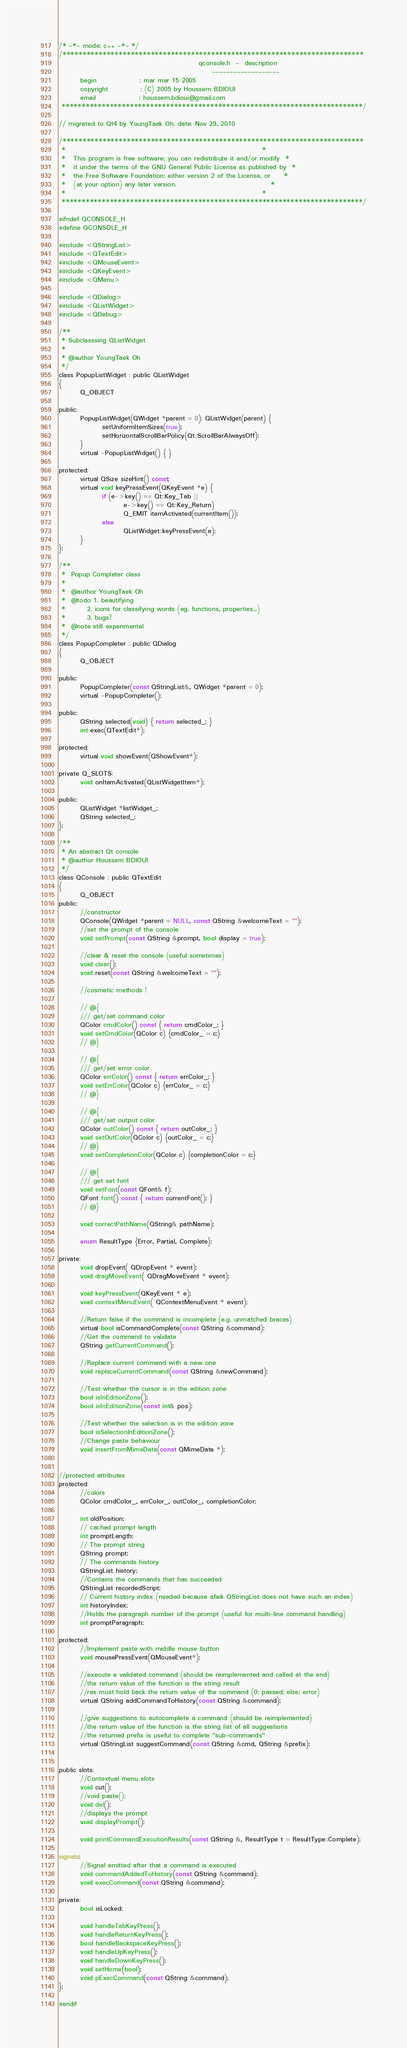Convert code to text. <code><loc_0><loc_0><loc_500><loc_500><_C_>/* -*- mode: c++ -*- */
/***************************************************************************
                                                    qconsole.h  -  description
                                                         -------------------
        begin                : mar mar 15 2005
        copyright            : (C) 2005 by Houssem BDIOUI
        email                : houssem.bdioui@gmail.com
 ***************************************************************************/

// migrated to Qt4 by YoungTaek Oh. date: Nov 29, 2010

/***************************************************************************
 *                                                                         *
 *   This program is free software; you can redistribute it and/or modify  *
 *   it under the terms of the GNU General Public License as published by  *
 *   the Free Software Foundation; either version 2 of the License, or     *
 *   (at your option) any later version.                                   *
 *                                                                         *
 ***************************************************************************/

#ifndef QCONSOLE_H
#define QCONSOLE_H

#include <QStringList>
#include <QTextEdit>
#include <QMouseEvent>
#include <QKeyEvent>
#include <QMenu>

#include <QDialog>
#include <QListWidget>
#include <QDebug>

/**
 * Subclasssing QListWidget
 *
 * @author YoungTaek Oh
 */
class PopupListWidget : public QListWidget
{
        Q_OBJECT

public:
        PopupListWidget(QWidget *parent = 0): QListWidget(parent) {
                setUniformItemSizes(true);
                setHorizontalScrollBarPolicy(Qt::ScrollBarAlwaysOff);
        }
        virtual ~PopupListWidget() { }

protected:
        virtual QSize sizeHint() const;
        virtual void keyPressEvent(QKeyEvent *e) {
                if (e->key() == Qt::Key_Tab ||
                        e->key() == Qt::Key_Return)
                        Q_EMIT itemActivated(currentItem());
                else
                        QListWidget::keyPressEvent(e);
        }
};

/**
 *  Popup Completer class
 *
 *  @author YoungTaek Oh
 *  @todo 1. beautifying
 *        2. icons for classifying words (eg. functions, properties...)
 *        3. bugs?
 *  @note still experimental
 */
class PopupCompleter : public QDialog
{
        Q_OBJECT

public:
        PopupCompleter(const QStringList&, QWidget *parent = 0);
        virtual ~PopupCompleter();

public:
        QString selected(void) { return selected_; }
        int exec(QTextEdit*);

protected:
        virtual void showEvent(QShowEvent*);

private Q_SLOTS:
        void onItemActivated(QListWidgetItem*);

public:
        QListWidget *listWidget_;
        QString selected_;
};

/**
 * An abstract Qt console
 * @author Houssem BDIOUI
 */
class QConsole : public QTextEdit
{
        Q_OBJECT
public:
        //constructor
        QConsole(QWidget *parent = NULL, const QString &welcomeText = "");
        //set the prompt of the console
        void setPrompt(const QString &prompt, bool display = true);

        //clear & reset the console (useful sometimes)
        void clear();
        void reset(const QString &welcomeText = "");

        //cosmetic methods !

        // @{
        /// get/set command color
        QColor cmdColor() const { return cmdColor_; }
        void setCmdColor(QColor c) {cmdColor_ = c;}
        // @}

        // @{
        /// get/set error color
        QColor errColor() const { return errColor_; }
        void setErrColor(QColor c) {errColor_ = c;}
        // @}

        // @{
        /// get/set output color
        QColor outColor() const { return outColor_; }
        void setOutColor(QColor c) {outColor_ = c;}
        // @}
        void setCompletionColor(QColor c) {completionColor = c;}

        // @{
        /// get set font
        void setFont(const QFont& f);
        QFont font() const { return currentFont(); }
        // @}

        void correctPathName(QString& pathName);

        enum ResultType {Error, Partial, Complete};

private:
        void dropEvent( QDropEvent * event);
        void dragMoveEvent( QDragMoveEvent * event);

        void keyPressEvent(QKeyEvent * e);
        void contextMenuEvent( QContextMenuEvent * event);

        //Return false if the command is incomplete (e.g. unmatched braces)
        virtual bool isCommandComplete(const QString &command);
        //Get the command to validate
        QString getCurrentCommand();

        //Replace current command with a new one
        void replaceCurrentCommand(const QString &newCommand);

        //Test whether the cursor is in the edition zone
        bool isInEditionZone();
        bool isInEditionZone(const int& pos);

        //Test whether the selection is in the edition zone
        bool isSelectionInEditionZone();
        //Change paste behaviour
        void insertFromMimeData(const QMimeData *);


//protected attributes
protected:
        //colors
        QColor cmdColor_, errColor_, outColor_, completionColor;

        int oldPosition;
        // cached prompt length
        int promptLength;
        // The prompt string
        QString prompt;
        // The commands history
        QStringList history;
        //Contains the commands that has succeeded
        QStringList recordedScript;
        // Current history index (needed because afaik QStringList does not have such an index)
        int historyIndex;
        //Holds the paragraph number of the prompt (useful for multi-line command handling)
        int promptParagraph;

protected:
        //Implement paste with middle mouse button
        void mousePressEvent(QMouseEvent*);

        //execute a validated command (should be reimplemented and called at the end)
        //the return value of the function is the string result
        //res must hold back the return value of the command (0: passed; else: error)
        virtual QString addCommandToHistory(const QString &command);

        //give suggestions to autocomplete a command (should be reimplemented)
        //the return value of the function is the string list of all suggestions
        //the returned prefix is useful to complete "sub-commands"
        virtual QStringList suggestCommand(const QString &cmd, QString &prefix);


public slots:
        //Contextual menu slots
        void cut();
        //void paste();
        void del();
        //displays the prompt
        void displayPrompt();

        void printCommandExecutionResults(const QString &, ResultType t = ResultType::Complete);

signals:
        //Signal emitted after that a command is executed
        void commandAddedToHistory(const QString &command);
        void execCommand(const QString &command);

private:
        bool isLocked;

        void handleTabKeyPress();
        void handleReturnKeyPress();
        bool handleBackspaceKeyPress();
        void handleUpKeyPress();
        void handleDownKeyPress();
        void setHome(bool);
        void pExecCommand(const QString &command);
};

#endif
</code> 